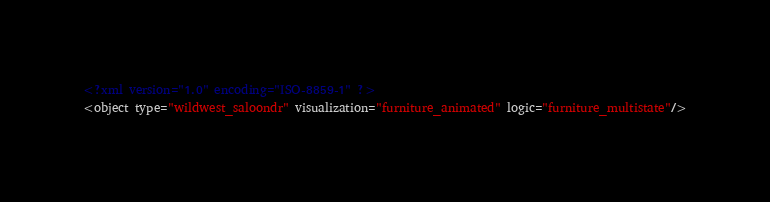Convert code to text. <code><loc_0><loc_0><loc_500><loc_500><_XML_><?xml version="1.0" encoding="ISO-8859-1" ?><object type="wildwest_saloondr" visualization="furniture_animated" logic="furniture_multistate"/></code> 